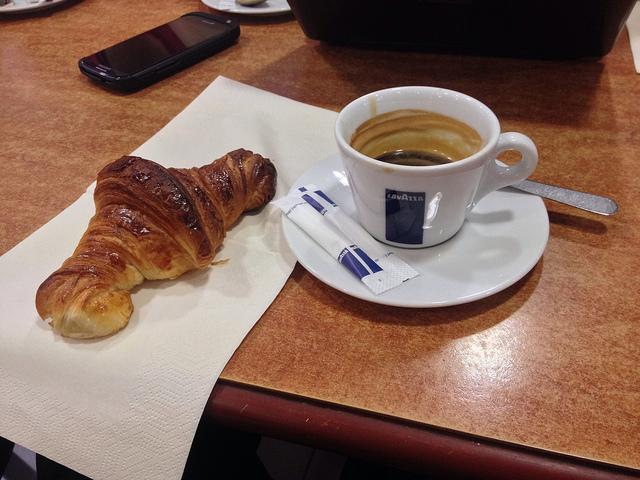What color is the block in the middle of the cup on the right? blue 